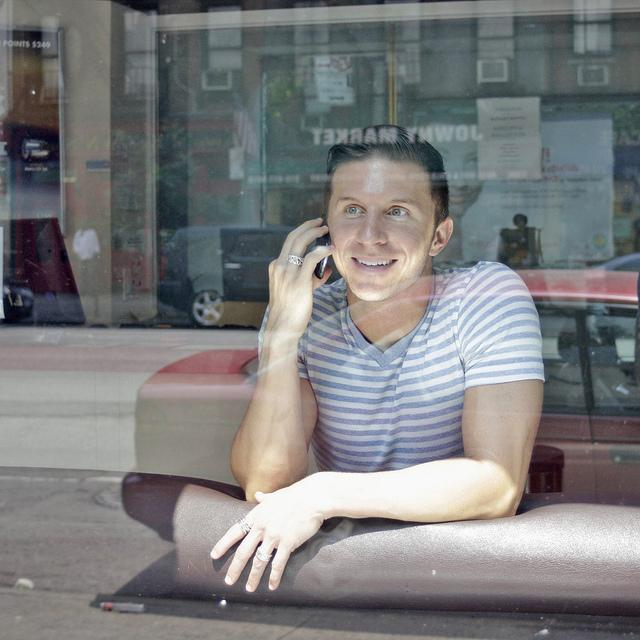What is the man on the phone sitting behind?

Choices:
A) plastic
B) glass
C) foil
D) paper glass 